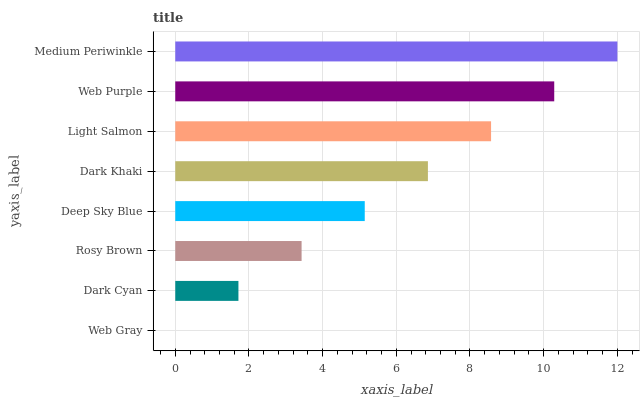Is Web Gray the minimum?
Answer yes or no. Yes. Is Medium Periwinkle the maximum?
Answer yes or no. Yes. Is Dark Cyan the minimum?
Answer yes or no. No. Is Dark Cyan the maximum?
Answer yes or no. No. Is Dark Cyan greater than Web Gray?
Answer yes or no. Yes. Is Web Gray less than Dark Cyan?
Answer yes or no. Yes. Is Web Gray greater than Dark Cyan?
Answer yes or no. No. Is Dark Cyan less than Web Gray?
Answer yes or no. No. Is Dark Khaki the high median?
Answer yes or no. Yes. Is Deep Sky Blue the low median?
Answer yes or no. Yes. Is Dark Cyan the high median?
Answer yes or no. No. Is Rosy Brown the low median?
Answer yes or no. No. 